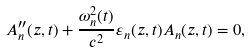Convert formula to latex. <formula><loc_0><loc_0><loc_500><loc_500>A _ { n } ^ { \prime \prime } ( z , t ) + \frac { \omega _ { n } ^ { 2 } ( t ) } { c ^ { 2 } } \varepsilon _ { n } ( z , t ) A _ { n } ( z , t ) = 0 ,</formula> 